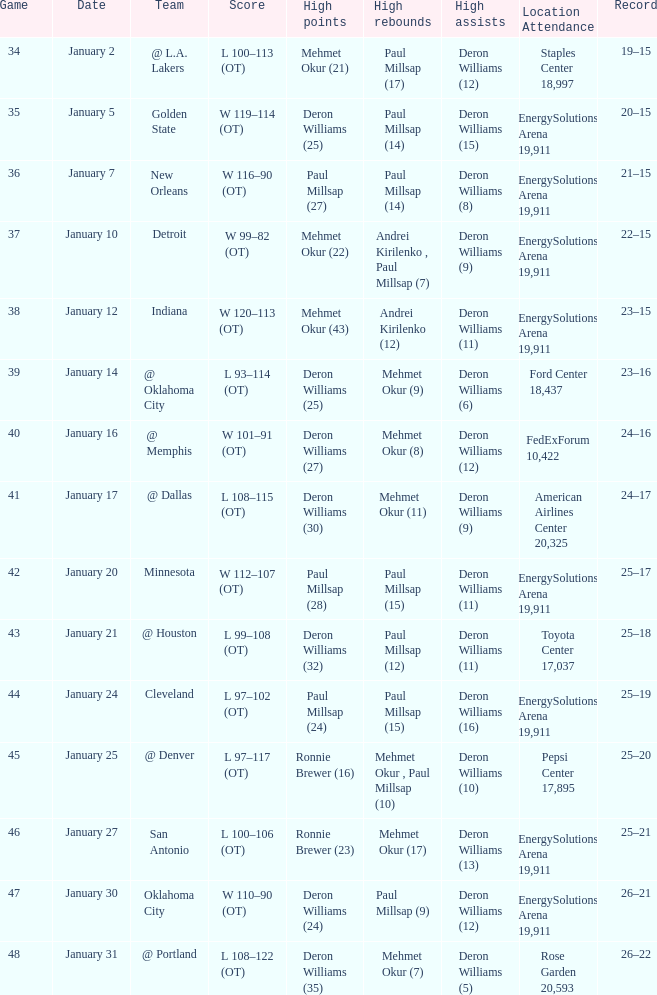Who had the high rebounds on January 24? Paul Millsap (15). 